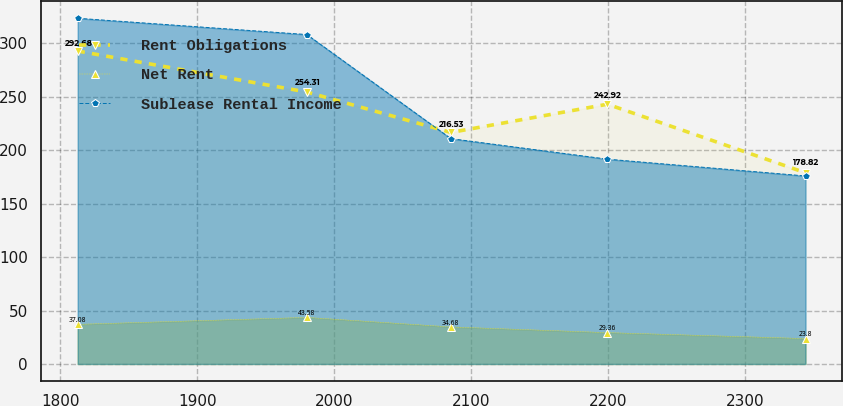Convert chart. <chart><loc_0><loc_0><loc_500><loc_500><line_chart><ecel><fcel>Rent Obligations<fcel>Net Rent<fcel>Sublease Rental Income<nl><fcel>1812.61<fcel>292.68<fcel>37.08<fcel>323.29<nl><fcel>1979.91<fcel>254.31<fcel>43.58<fcel>308.06<nl><fcel>2084.99<fcel>216.53<fcel>34.68<fcel>210.74<nl><fcel>2199.27<fcel>242.92<fcel>29.36<fcel>191.54<nl><fcel>2343.84<fcel>178.82<fcel>23.8<fcel>175.82<nl></chart> 